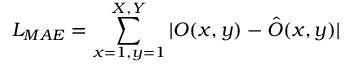Convert formula to latex. <formula><loc_0><loc_0><loc_500><loc_500>L _ { M A E } = \sum _ { x = 1 , y = 1 } ^ { X , Y } | O ( x , y ) - \hat { O } ( x , y ) |</formula> 